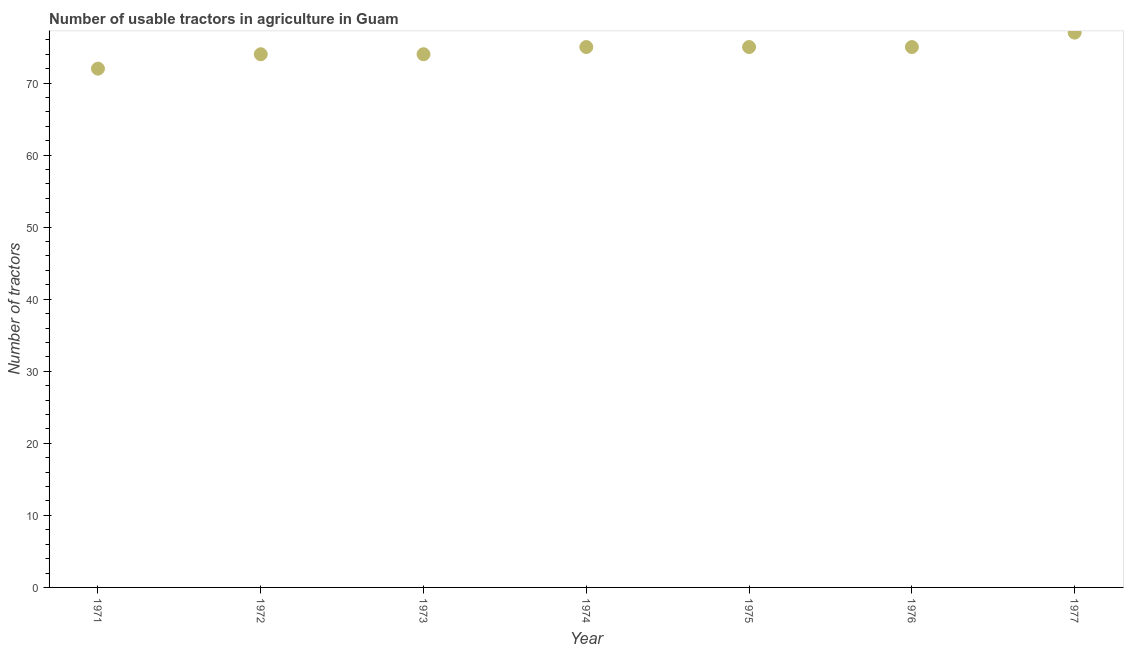What is the number of tractors in 1976?
Your answer should be compact. 75. Across all years, what is the maximum number of tractors?
Your answer should be very brief. 77. Across all years, what is the minimum number of tractors?
Give a very brief answer. 72. In which year was the number of tractors maximum?
Offer a terse response. 1977. What is the sum of the number of tractors?
Give a very brief answer. 522. What is the difference between the number of tractors in 1975 and 1976?
Provide a short and direct response. 0. What is the average number of tractors per year?
Your response must be concise. 74.57. In how many years, is the number of tractors greater than 56 ?
Keep it short and to the point. 7. Do a majority of the years between 1977 and 1972 (inclusive) have number of tractors greater than 4 ?
Provide a succinct answer. Yes. What is the ratio of the number of tractors in 1972 to that in 1977?
Your response must be concise. 0.96. What is the difference between the highest and the second highest number of tractors?
Offer a terse response. 2. What is the difference between the highest and the lowest number of tractors?
Provide a succinct answer. 5. How many years are there in the graph?
Provide a short and direct response. 7. Are the values on the major ticks of Y-axis written in scientific E-notation?
Offer a terse response. No. Does the graph contain any zero values?
Offer a terse response. No. Does the graph contain grids?
Ensure brevity in your answer.  No. What is the title of the graph?
Give a very brief answer. Number of usable tractors in agriculture in Guam. What is the label or title of the X-axis?
Your answer should be compact. Year. What is the label or title of the Y-axis?
Offer a very short reply. Number of tractors. What is the Number of tractors in 1971?
Ensure brevity in your answer.  72. What is the Number of tractors in 1973?
Keep it short and to the point. 74. What is the Number of tractors in 1974?
Provide a succinct answer. 75. What is the Number of tractors in 1976?
Provide a succinct answer. 75. What is the difference between the Number of tractors in 1971 and 1972?
Provide a succinct answer. -2. What is the difference between the Number of tractors in 1971 and 1973?
Provide a short and direct response. -2. What is the difference between the Number of tractors in 1971 and 1975?
Ensure brevity in your answer.  -3. What is the difference between the Number of tractors in 1971 and 1976?
Your answer should be very brief. -3. What is the difference between the Number of tractors in 1971 and 1977?
Your answer should be compact. -5. What is the difference between the Number of tractors in 1972 and 1973?
Give a very brief answer. 0. What is the difference between the Number of tractors in 1972 and 1977?
Your response must be concise. -3. What is the difference between the Number of tractors in 1973 and 1974?
Provide a short and direct response. -1. What is the difference between the Number of tractors in 1974 and 1976?
Make the answer very short. 0. What is the difference between the Number of tractors in 1974 and 1977?
Give a very brief answer. -2. What is the difference between the Number of tractors in 1975 and 1976?
Keep it short and to the point. 0. What is the difference between the Number of tractors in 1976 and 1977?
Offer a very short reply. -2. What is the ratio of the Number of tractors in 1971 to that in 1972?
Provide a succinct answer. 0.97. What is the ratio of the Number of tractors in 1971 to that in 1973?
Give a very brief answer. 0.97. What is the ratio of the Number of tractors in 1971 to that in 1975?
Give a very brief answer. 0.96. What is the ratio of the Number of tractors in 1971 to that in 1976?
Keep it short and to the point. 0.96. What is the ratio of the Number of tractors in 1971 to that in 1977?
Offer a very short reply. 0.94. What is the ratio of the Number of tractors in 1972 to that in 1973?
Offer a terse response. 1. What is the ratio of the Number of tractors in 1972 to that in 1975?
Your response must be concise. 0.99. What is the ratio of the Number of tractors in 1972 to that in 1976?
Provide a short and direct response. 0.99. What is the ratio of the Number of tractors in 1972 to that in 1977?
Your answer should be compact. 0.96. What is the ratio of the Number of tractors in 1973 to that in 1974?
Provide a succinct answer. 0.99. What is the ratio of the Number of tractors in 1973 to that in 1975?
Keep it short and to the point. 0.99. What is the ratio of the Number of tractors in 1974 to that in 1975?
Keep it short and to the point. 1. What is the ratio of the Number of tractors in 1974 to that in 1976?
Your answer should be compact. 1. What is the ratio of the Number of tractors in 1975 to that in 1976?
Provide a succinct answer. 1. What is the ratio of the Number of tractors in 1975 to that in 1977?
Your response must be concise. 0.97. 